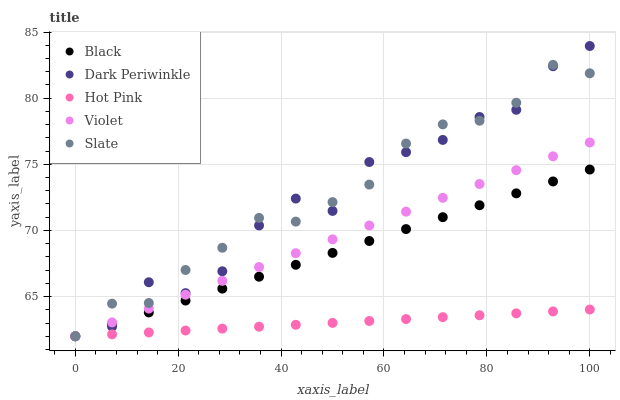Does Hot Pink have the minimum area under the curve?
Answer yes or no. Yes. Does Slate have the maximum area under the curve?
Answer yes or no. Yes. Does Black have the minimum area under the curve?
Answer yes or no. No. Does Black have the maximum area under the curve?
Answer yes or no. No. Is Hot Pink the smoothest?
Answer yes or no. Yes. Is Dark Periwinkle the roughest?
Answer yes or no. Yes. Is Black the smoothest?
Answer yes or no. No. Is Black the roughest?
Answer yes or no. No. Does Slate have the lowest value?
Answer yes or no. Yes. Does Dark Periwinkle have the highest value?
Answer yes or no. Yes. Does Black have the highest value?
Answer yes or no. No. Does Black intersect Dark Periwinkle?
Answer yes or no. Yes. Is Black less than Dark Periwinkle?
Answer yes or no. No. Is Black greater than Dark Periwinkle?
Answer yes or no. No. 